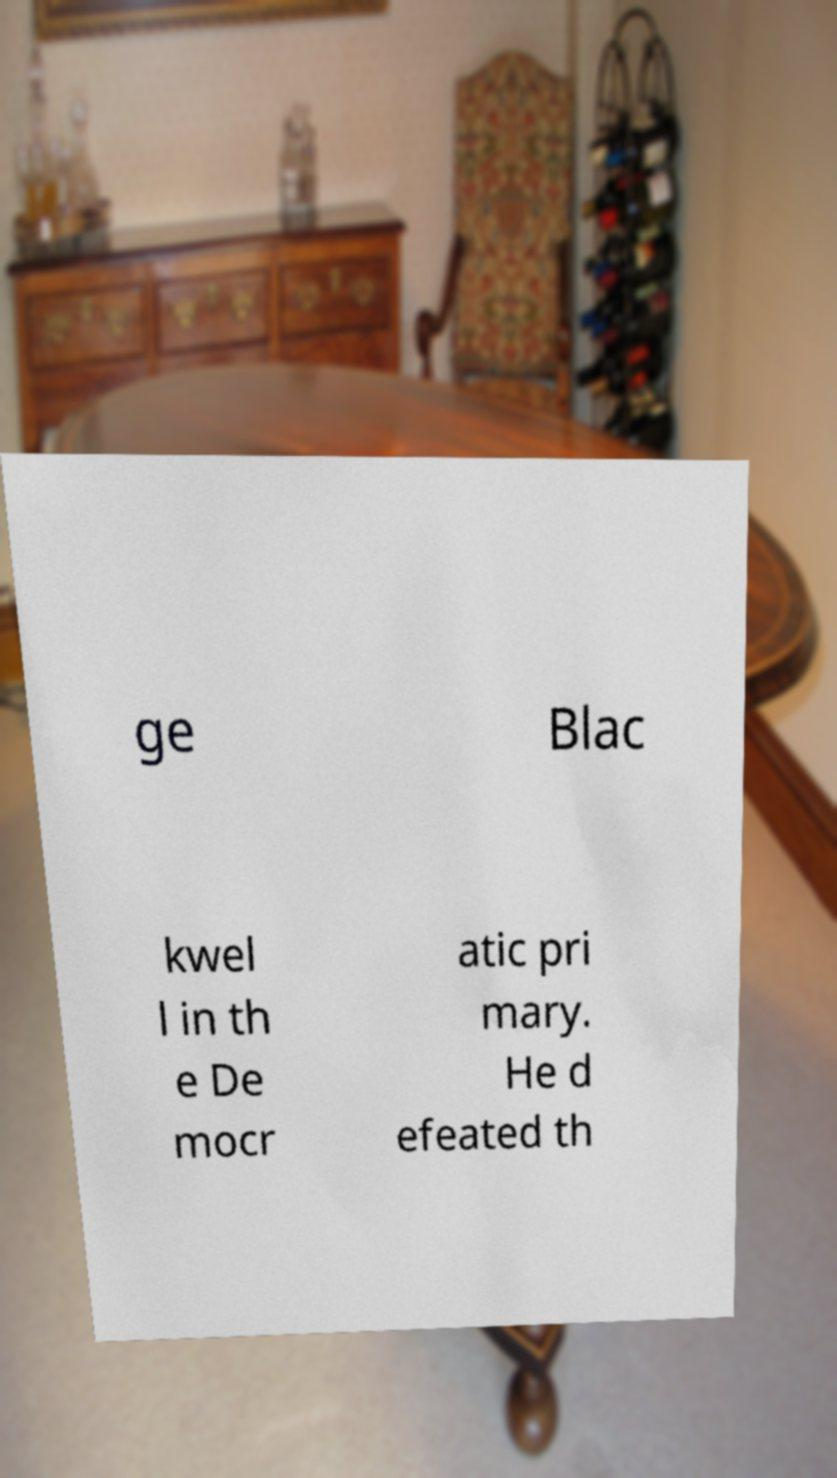Could you extract and type out the text from this image? ge Blac kwel l in th e De mocr atic pri mary. He d efeated th 